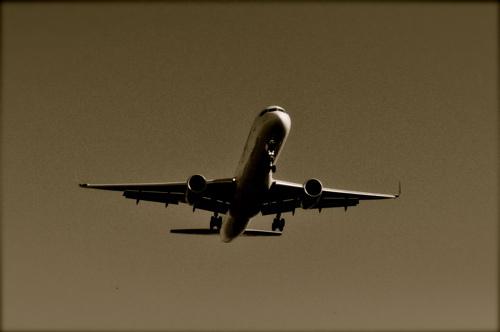Is it flying or landing?
Write a very short answer. Flying. Who is the photographer?
Concise answer only. Unknown. How many engines does this aircraft have?
Short answer required. 2. What does the plane say above the wing?
Answer briefly. United. Are there any clouds in the picture?
Concise answer only. No. What color is the sky?
Give a very brief answer. Gray. 